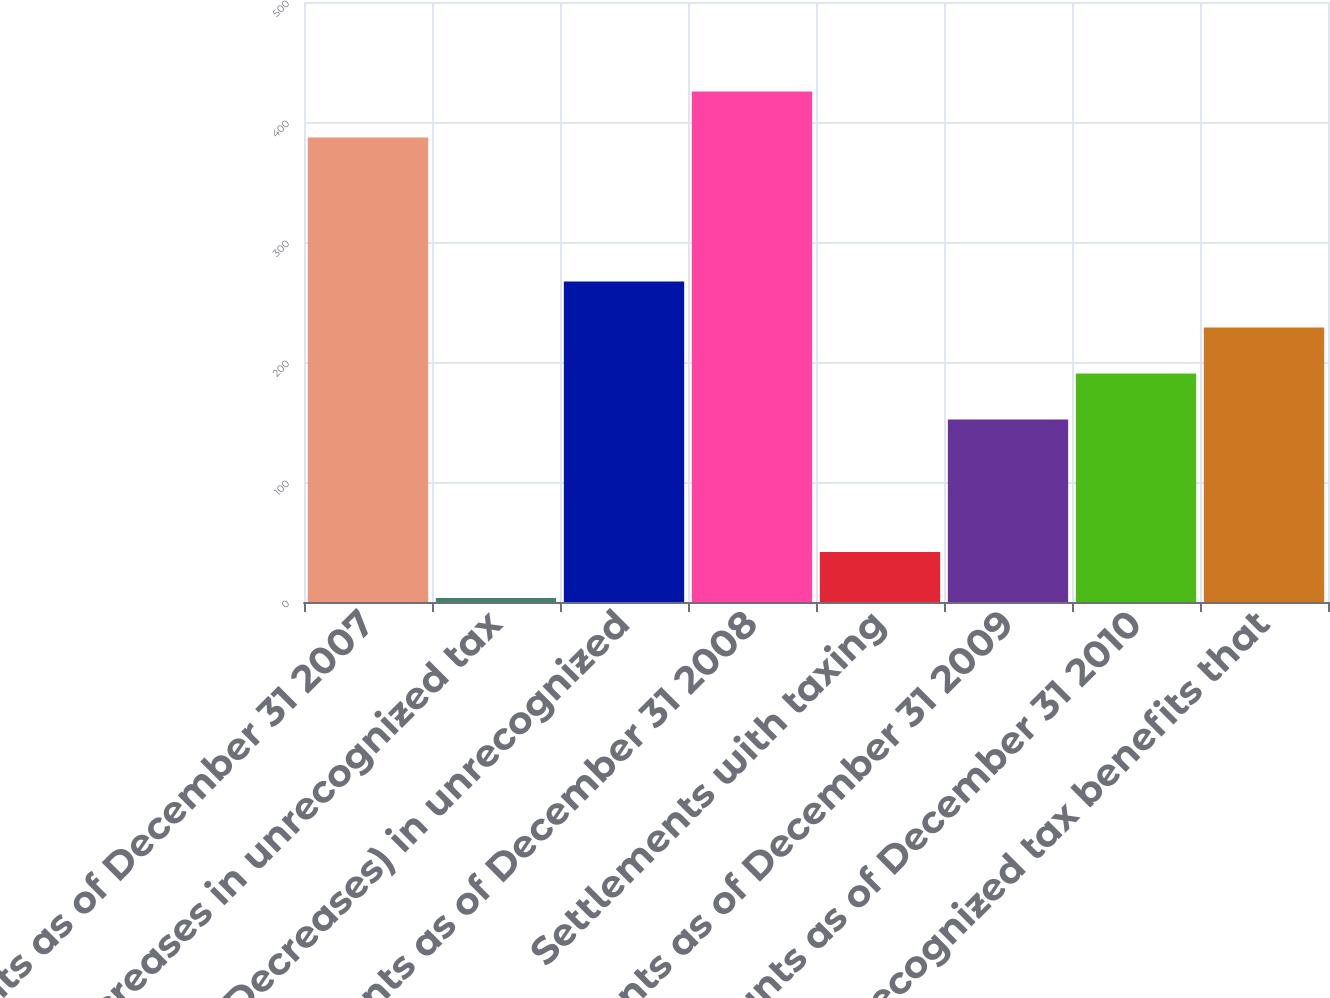Convert chart. <chart><loc_0><loc_0><loc_500><loc_500><bar_chart><fcel>Amounts as of December 31 2007<fcel>Increases in unrecognized tax<fcel>(Decreases) in unrecognized<fcel>Amounts as of December 31 2008<fcel>Settlements with taxing<fcel>Amounts as of December 31 2009<fcel>Amounts as of December 31 2010<fcel>Unrecognized tax benefits that<nl><fcel>387<fcel>3.3<fcel>267.11<fcel>425.37<fcel>41.67<fcel>152<fcel>190.37<fcel>228.74<nl></chart> 